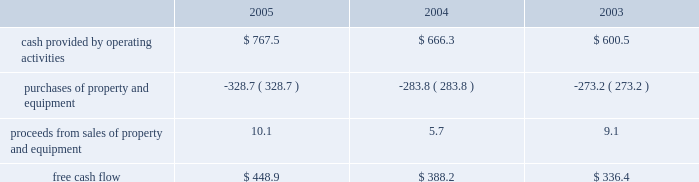The fair value of variable rate debt approximates the carrying value since interest rates are variable and , thus , approximate current market rates .
Free cash flow we define free cash flow , which is not a measure determined in accordance with generally accepted accounting principles in the united states , as cash provided by operating activities less purchases of property and equipment plus proceeds from sales of property and equipment as presented in our consolidated statements of cash flows .
Our free cash flow for the years ended december 31 , 2005 , 2004 and 2003 is calculated as follows ( in millions ) : .
Free cash flow for the year ended december 31 , 2005 was higher than the previous years presented primarily because of a $ 113.4 million federal tax payment that was deferred until february 2006 as a result of an internal revenue service notice issued in response to hurricane katrina , and the timing of payments for capital and other expenditures .
As a result of the timing of these payments , we expect free cash flow during 2006 to be lower than 2005 .
We believe that the presentation of free cash flow provides useful information regarding our recurring cash provided by operating activities after expenditures for property and equipment , net of proceeds from sales of property and equipment .
It also demonstrates our ability to execute our financial strategy which includes reinvesting in existing capital assets to ensure a high level of customer service , investing in capital assets to facilitate growth in our customer base and services provided , pursuing strategic acquisitions that augment our existing business platform , repurchasing shares of common stock at prices that provide value to our shareholders , paying cash dividends , maintaining our investment grade rating and minimizing debt .
In addition , free cash flow is a key metric used to determine compensation .
The presentation of free cash flow has material limitations .
Free cash flow does not represent our cash flow available for discretionary expenditures because it excludes certain expenditures that are required or that we have committed to such as debt service requirements and dividend payments .
Our definition of free cash flow may not be comparable to similarly titled measures presented by other companies .
Seasonality our operations can be adversely affected by periods of inclement weather which could increase the volume of waste collected under our existing contracts ( without corresponding compensation ) , delay the collection and disposal of waste , reduce the volume of waste delivered to our disposal sites , or delay the construction or expansion of our landfill sites and other facilities .
New accounting pronouncements on december 16 , 2004 , the financial accounting standards board issued statement of financial accounting standards no .
123 ( revised 2004 ) , 201cshare-based payment , 201d which is a revision of sfas 123 , 201caccounting for stock-based compensation . 201d sfas 123 ( r ) supersedes apb opinion no .
25 , 201caccounting for stock issued to employees , 201d and amends sfas 95 , 201cstatement of cash flows . 201d generally , the approach in sfas 123 ( r ) is similar to the approach described in sfas 123 .
However , sfas 123 ( r ) requires all share-based payments to employees , including grants of employee stock options , to be recognized in the income statement based on their fair values .
Pro forma disclosure is no longer an alternative .
We are required to adopt sfas 123 ( r ) on january 1 , 2006 and expect to use the 201cmodified-prospective 201d method in which compensation cost will be recognized beginning with the effective date based on the requirements of sfas 123 ( r ) for all share-based payments granted after the effective date. .
What was the percent of the increase in proceeds from sales of property and equipment from 2004 to 2005? 
Rationale: the proceeds from sales of property and equipment from 2004 to 2005 increased by 77.2%
Computations: ((10.1 - 5.7) / 5.7)
Answer: 0.77193. 